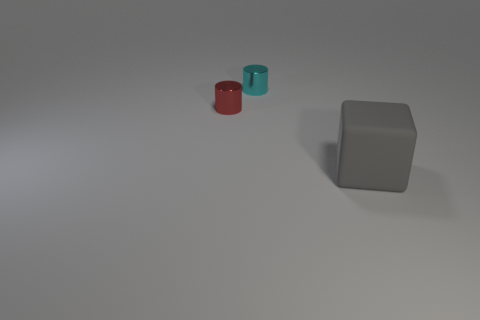Are there any other things that have the same size as the gray matte block?
Provide a succinct answer. No. Is there anything else that has the same shape as the large gray thing?
Ensure brevity in your answer.  No. What is the shape of the cyan thing?
Provide a short and direct response. Cylinder. Is the shape of the tiny object that is behind the small red cylinder the same as  the red thing?
Provide a succinct answer. Yes. Is the number of shiny cylinders that are on the left side of the big gray cube greater than the number of cubes to the left of the small red metal object?
Ensure brevity in your answer.  Yes. What number of other objects are the same size as the matte block?
Offer a very short reply. 0. Does the cyan thing have the same shape as the shiny object that is in front of the cyan thing?
Your response must be concise. Yes. How many matte objects are blue blocks or red things?
Your answer should be compact. 0. Are there any red cylinders?
Your answer should be very brief. Yes. Is the big gray matte thing the same shape as the red object?
Ensure brevity in your answer.  No. 